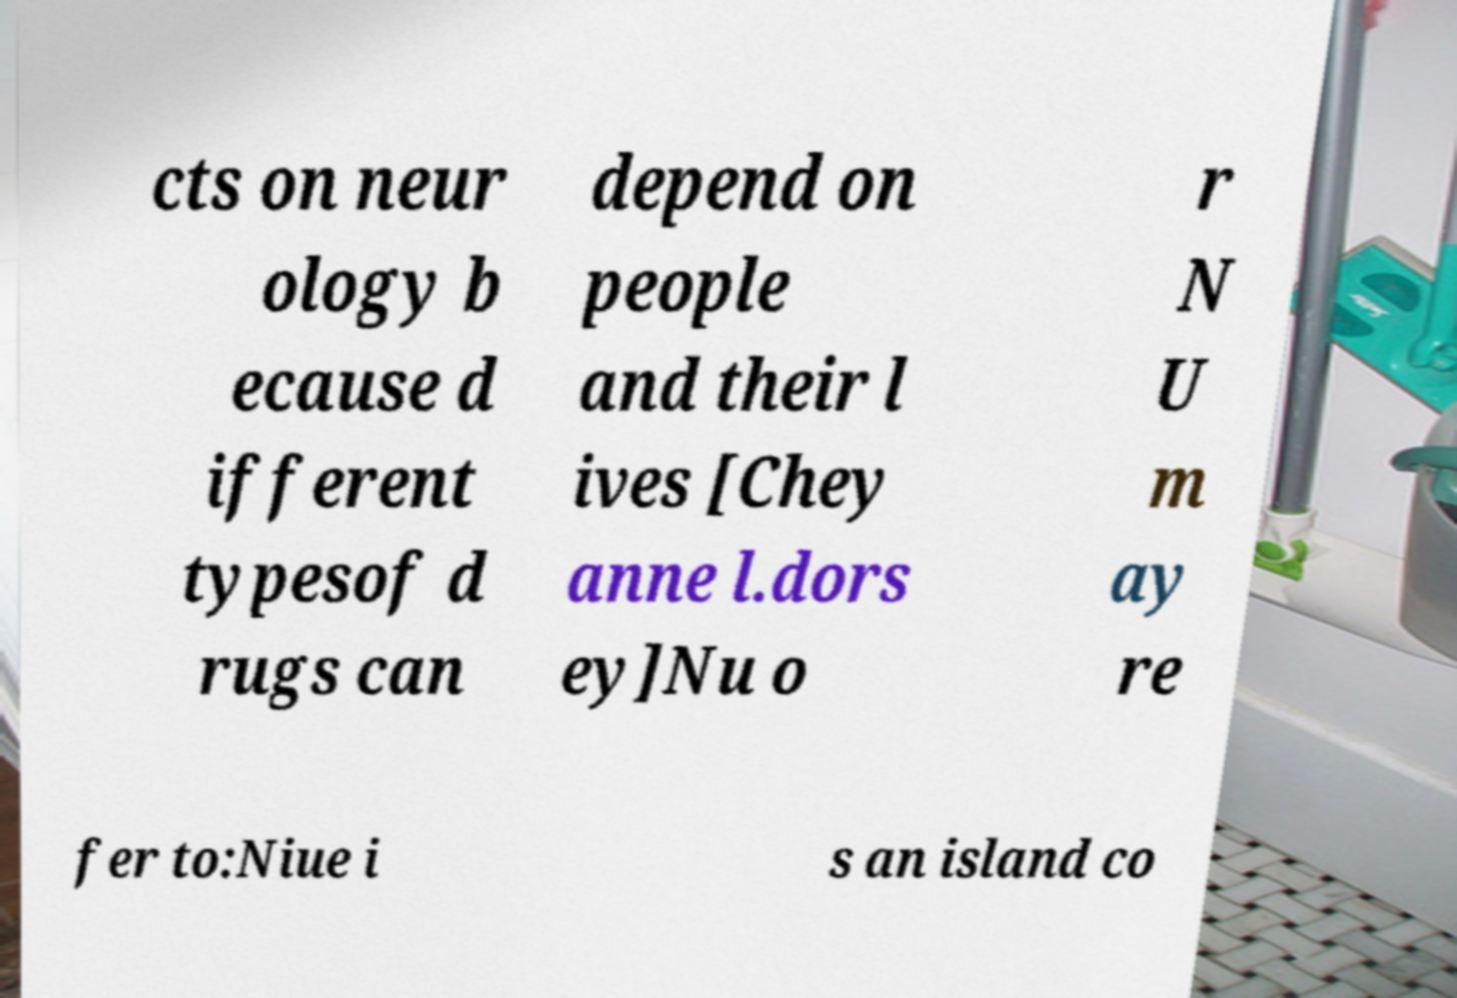Please read and relay the text visible in this image. What does it say? cts on neur ology b ecause d ifferent typesof d rugs can depend on people and their l ives [Chey anne l.dors ey]Nu o r N U m ay re fer to:Niue i s an island co 